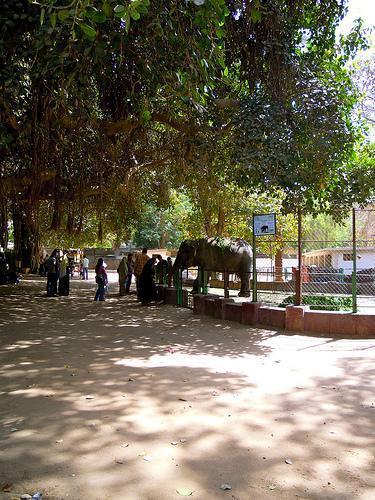How many elephants are visible?
Give a very brief answer. 1. 